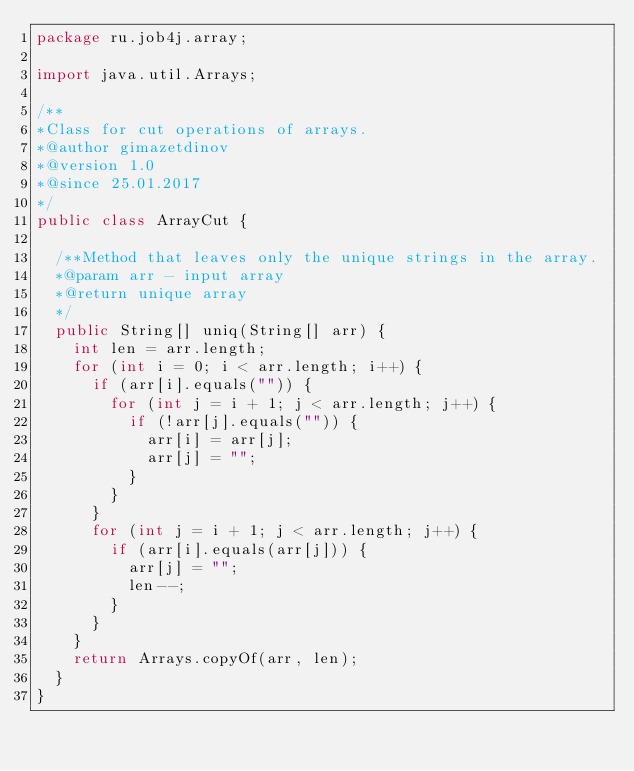<code> <loc_0><loc_0><loc_500><loc_500><_Java_>package ru.job4j.array;

import java.util.Arrays;

/**
*Class for cut operations of arrays.
*@author gimazetdinov
*@version 1.0
*@since 25.01.2017
*/
public class ArrayCut {

	/**Method that leaves only the unique strings in the array.
	*@param arr - input array
	*@return unique array
	*/
	public String[] uniq(String[] arr) {
		int len = arr.length;
		for (int i = 0; i < arr.length; i++) {
			if (arr[i].equals("")) {
				for (int j = i + 1; j < arr.length; j++) {
					if (!arr[j].equals("")) {
						arr[i] = arr[j];
						arr[j] = "";
					}
				}
			}
			for (int j = i + 1; j < arr.length; j++) {
				if (arr[i].equals(arr[j])) {
					arr[j] = "";
					len--;
				}
			}
		}
		return Arrays.copyOf(arr, len);
	}
}
</code> 